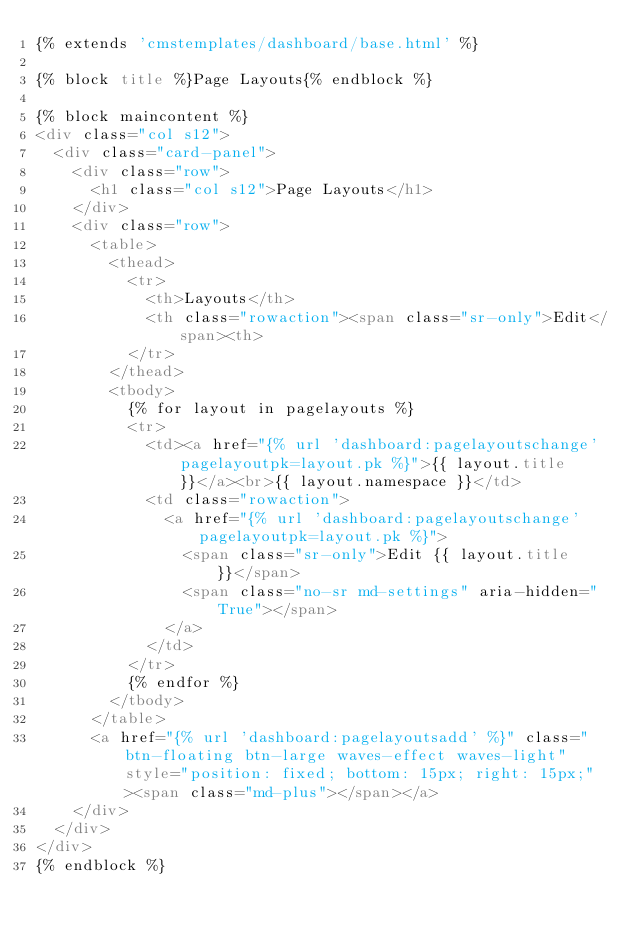Convert code to text. <code><loc_0><loc_0><loc_500><loc_500><_HTML_>{% extends 'cmstemplates/dashboard/base.html' %}

{% block title %}Page Layouts{% endblock %}

{% block maincontent %}
<div class="col s12">
  <div class="card-panel">
    <div class="row">
      <h1 class="col s12">Page Layouts</h1>
    </div>
    <div class="row">
      <table>
        <thead>
          <tr>
            <th>Layouts</th>
            <th class="rowaction"><span class="sr-only">Edit</span><th>
          </tr>
        </thead>
        <tbody>
          {% for layout in pagelayouts %}
          <tr>
            <td><a href="{% url 'dashboard:pagelayoutschange' pagelayoutpk=layout.pk %}">{{ layout.title }}</a><br>{{ layout.namespace }}</td>
            <td class="rowaction">
              <a href="{% url 'dashboard:pagelayoutschange' pagelayoutpk=layout.pk %}">
                <span class="sr-only">Edit {{ layout.title }}</span>
                <span class="no-sr md-settings" aria-hidden="True"></span>
              </a>
            </td>
          </tr>
          {% endfor %}
        </tbody>
      </table>
      <a href="{% url 'dashboard:pagelayoutsadd' %}" class="btn-floating btn-large waves-effect waves-light" style="position: fixed; bottom: 15px; right: 15px;"><span class="md-plus"></span></a>
    </div>
  </div>
</div>
{% endblock %}
</code> 